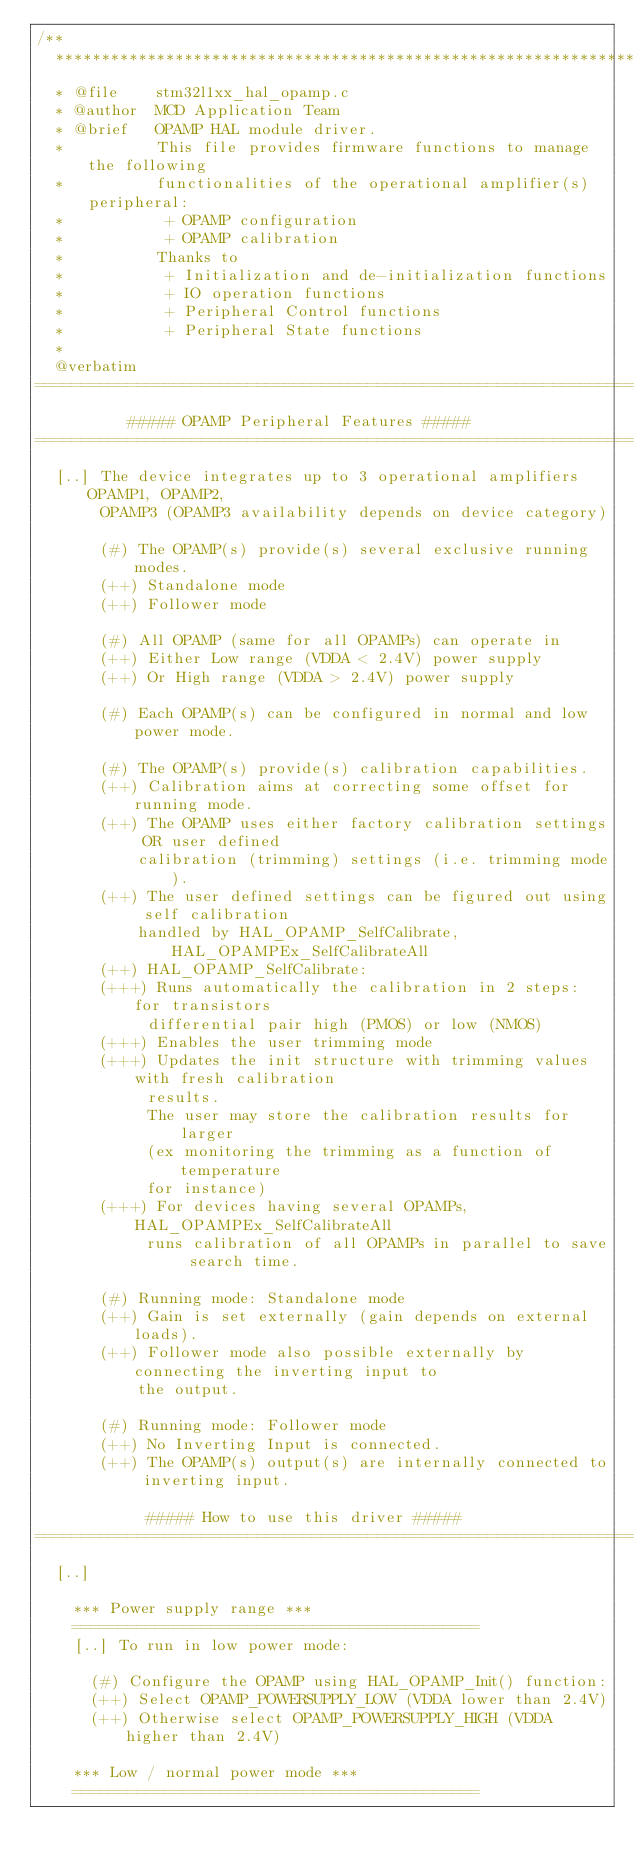Convert code to text. <code><loc_0><loc_0><loc_500><loc_500><_C_>/**
  ******************************************************************************
  * @file    stm32l1xx_hal_opamp.c
  * @author  MCD Application Team
  * @brief   OPAMP HAL module driver.
  *          This file provides firmware functions to manage the following
  *          functionalities of the operational amplifier(s) peripheral:
  *           + OPAMP configuration
  *           + OPAMP calibration
  *          Thanks to
  *           + Initialization and de-initialization functions
  *           + IO operation functions
  *           + Peripheral Control functions
  *           + Peripheral State functions
  *
  @verbatim
================================================================================
          ##### OPAMP Peripheral Features #####
================================================================================
  [..] The device integrates up to 3 operational amplifiers OPAMP1, OPAMP2,
       OPAMP3 (OPAMP3 availability depends on device category)

       (#) The OPAMP(s) provide(s) several exclusive running modes.
       (++) Standalone mode
       (++) Follower mode

       (#) All OPAMP (same for all OPAMPs) can operate in
       (++) Either Low range (VDDA < 2.4V) power supply
       (++) Or High range (VDDA > 2.4V) power supply

       (#) Each OPAMP(s) can be configured in normal and low power mode.

       (#) The OPAMP(s) provide(s) calibration capabilities.
       (++) Calibration aims at correcting some offset for running mode.
       (++) The OPAMP uses either factory calibration settings OR user defined
           calibration (trimming) settings (i.e. trimming mode).
       (++) The user defined settings can be figured out using self calibration
           handled by HAL_OPAMP_SelfCalibrate, HAL_OPAMPEx_SelfCalibrateAll
       (++) HAL_OPAMP_SelfCalibrate:
       (+++) Runs automatically the calibration in 2 steps: for transistors
            differential pair high (PMOS) or low (NMOS)
       (+++) Enables the user trimming mode
       (+++) Updates the init structure with trimming values with fresh calibration
            results.
            The user may store the calibration results for larger
            (ex monitoring the trimming as a function of temperature
            for instance)
       (+++) For devices having several OPAMPs, HAL_OPAMPEx_SelfCalibrateAll
            runs calibration of all OPAMPs in parallel to save search time.

       (#) Running mode: Standalone mode
       (++) Gain is set externally (gain depends on external loads).
       (++) Follower mode also possible externally by connecting the inverting input to
           the output.

       (#) Running mode: Follower mode
       (++) No Inverting Input is connected.
       (++) The OPAMP(s) output(s) are internally connected to inverting input.

            ##### How to use this driver #####
================================================================================
  [..]

    *** Power supply range ***
    ============================================
    [..] To run in low power mode:

      (#) Configure the OPAMP using HAL_OPAMP_Init() function:
      (++) Select OPAMP_POWERSUPPLY_LOW (VDDA lower than 2.4V)
      (++) Otherwise select OPAMP_POWERSUPPLY_HIGH (VDDA higher than 2.4V)

    *** Low / normal power mode ***
    ============================================</code> 